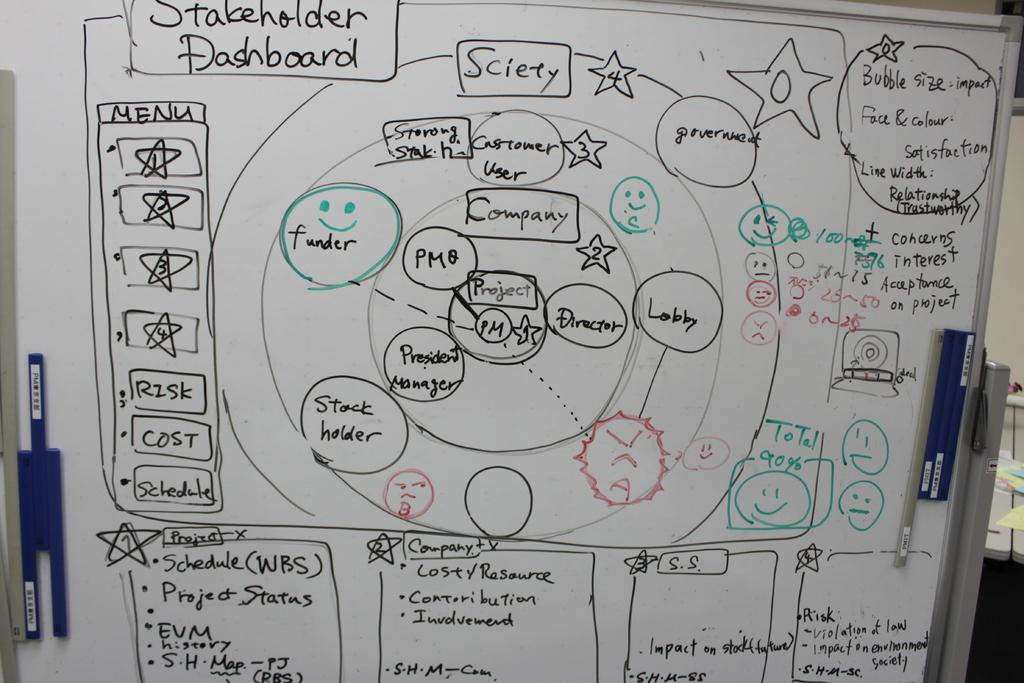<image>
Relay a brief, clear account of the picture shown. A white board that shows Stakeholder Dashboard information. 